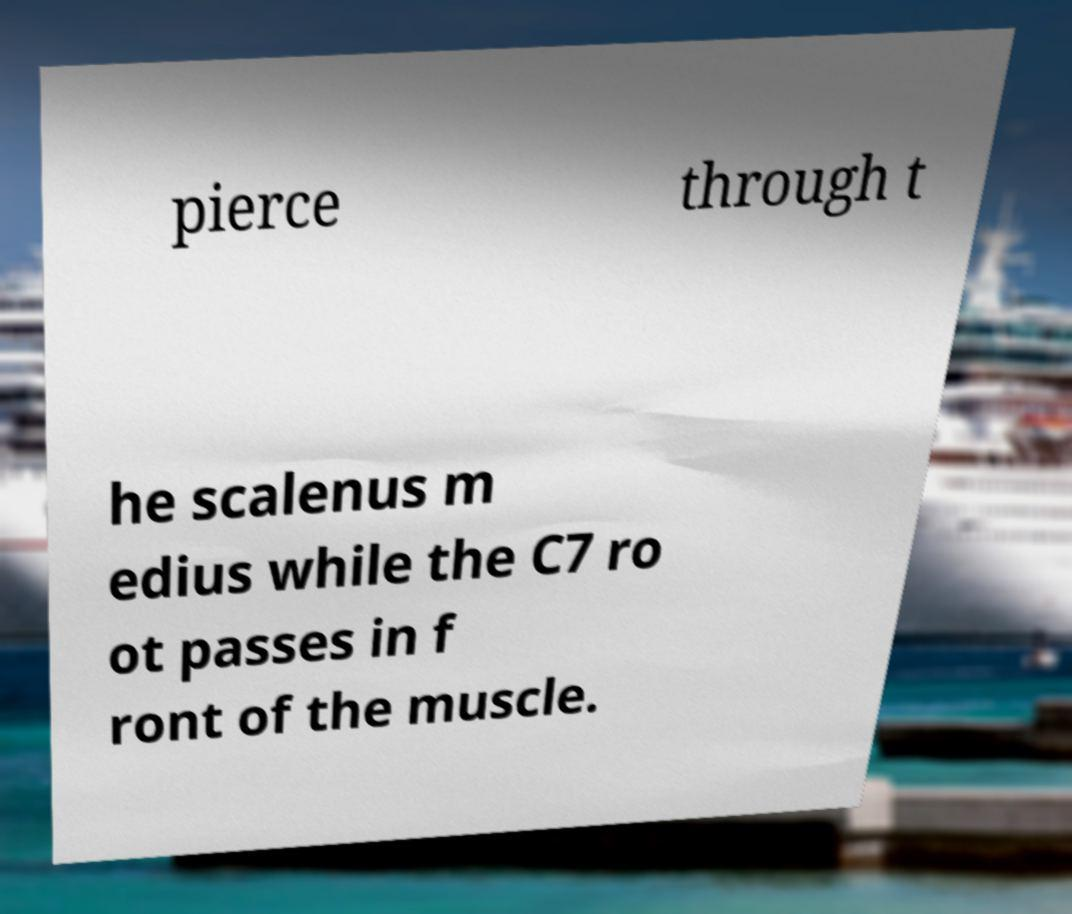Could you assist in decoding the text presented in this image and type it out clearly? pierce through t he scalenus m edius while the C7 ro ot passes in f ront of the muscle. 